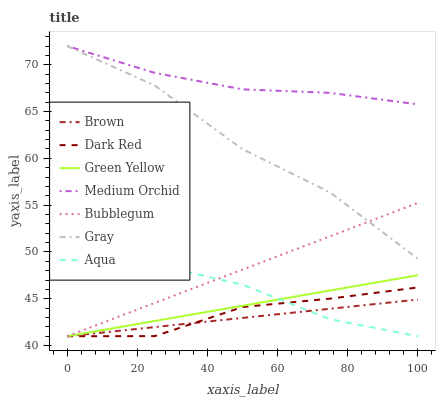Does Brown have the minimum area under the curve?
Answer yes or no. Yes. Does Medium Orchid have the maximum area under the curve?
Answer yes or no. Yes. Does Gray have the minimum area under the curve?
Answer yes or no. No. Does Gray have the maximum area under the curve?
Answer yes or no. No. Is Green Yellow the smoothest?
Answer yes or no. Yes. Is Gray the roughest?
Answer yes or no. Yes. Is Dark Red the smoothest?
Answer yes or no. No. Is Dark Red the roughest?
Answer yes or no. No. Does Brown have the lowest value?
Answer yes or no. Yes. Does Gray have the lowest value?
Answer yes or no. No. Does Medium Orchid have the highest value?
Answer yes or no. Yes. Does Dark Red have the highest value?
Answer yes or no. No. Is Aqua less than Gray?
Answer yes or no. Yes. Is Gray greater than Brown?
Answer yes or no. Yes. Does Gray intersect Medium Orchid?
Answer yes or no. Yes. Is Gray less than Medium Orchid?
Answer yes or no. No. Is Gray greater than Medium Orchid?
Answer yes or no. No. Does Aqua intersect Gray?
Answer yes or no. No. 